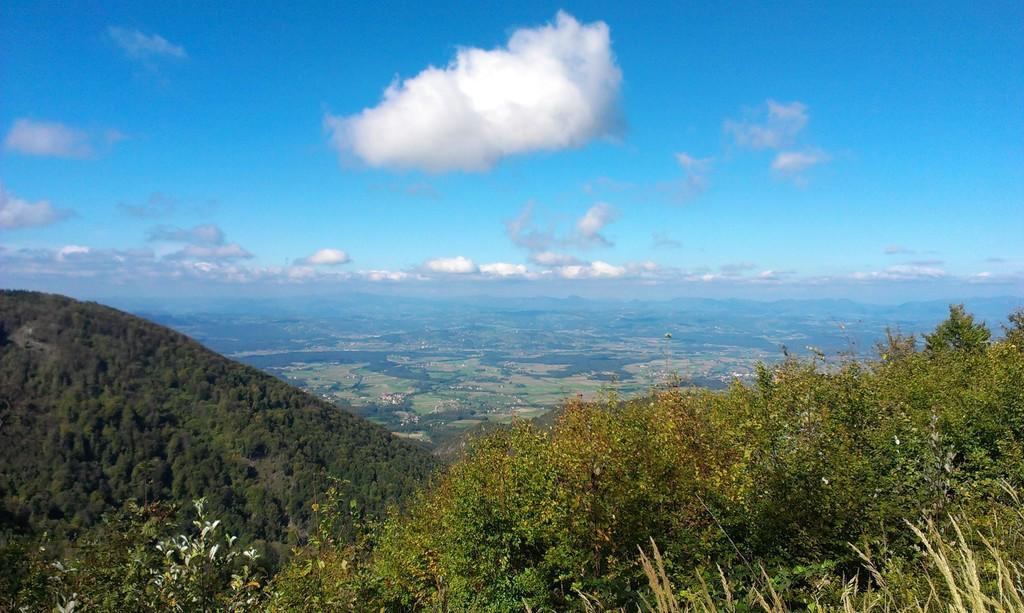Could you give a brief overview of what you see in this image? In this picture I can see trees, hills, and in the background there is the sky. 